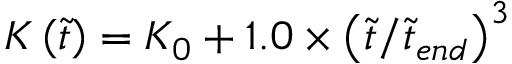<formula> <loc_0><loc_0><loc_500><loc_500>K \left ( \tilde { t } \right ) = K _ { 0 } + 1 . 0 \times \left ( \tilde { t } / \tilde { t } _ { e n d } \right ) ^ { 3 }</formula> 